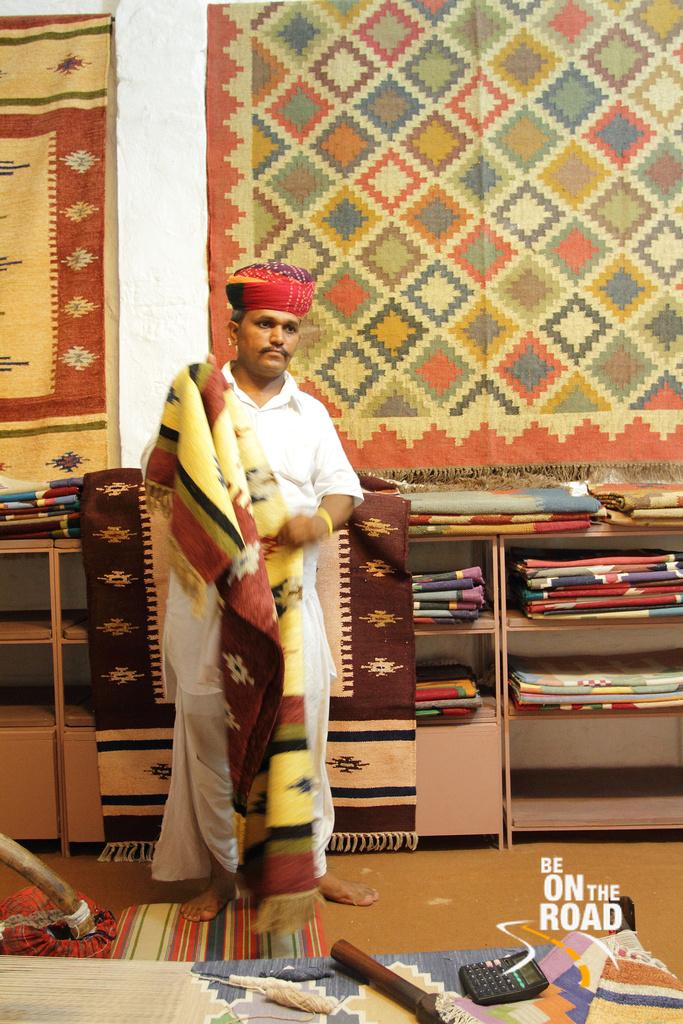What type of structure can be seen in the image? There is a wall in the image. What is placed on the floor in the image? There is a mat in the image. What type of objects are present in the image? There are cloths and a calculator in the image. What is the person in the image wearing? The person is wearing a white color dress in the image. What type of flower is growing on the wall in the image? There is no flower present on the wall in the image. What is the plot of the story being told in the image? The image does not depict a story or plot; it is a static scene. 